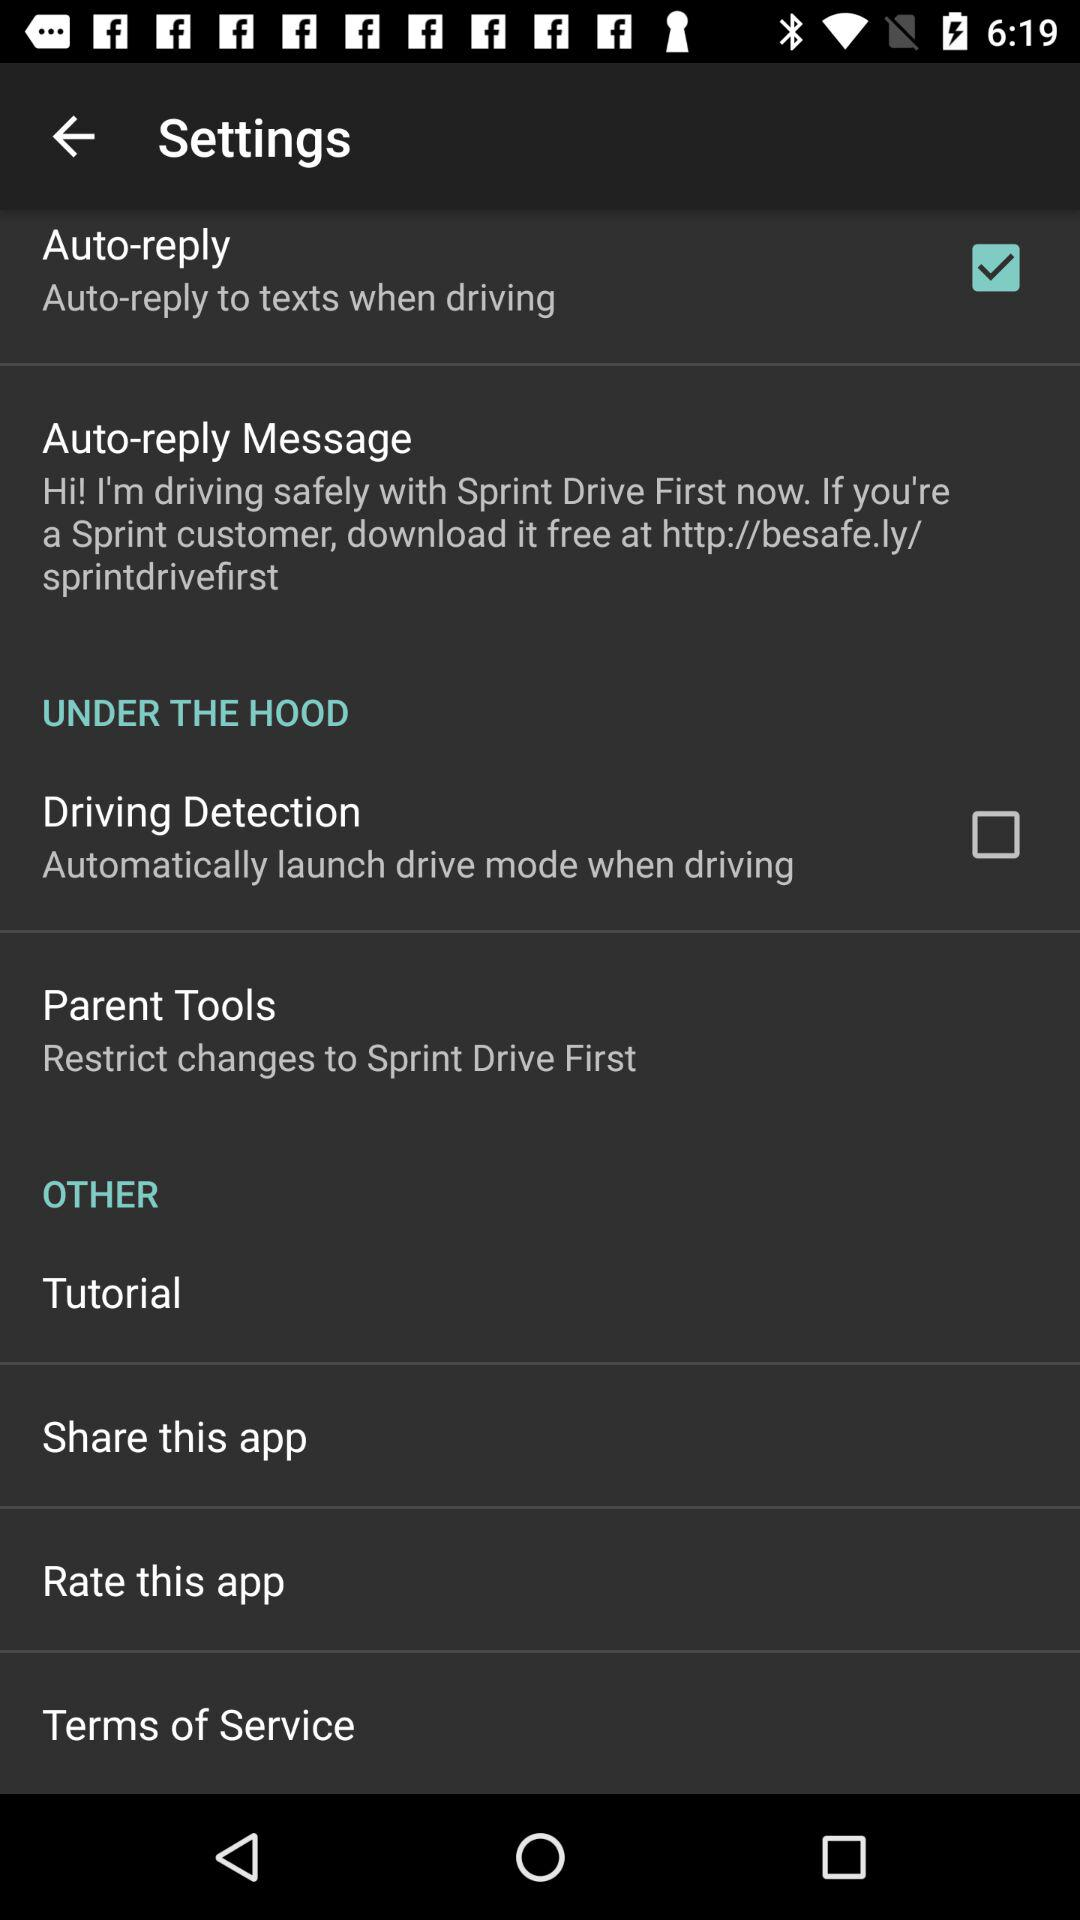How many items are under the Hood section?
Answer the question using a single word or phrase. 2 